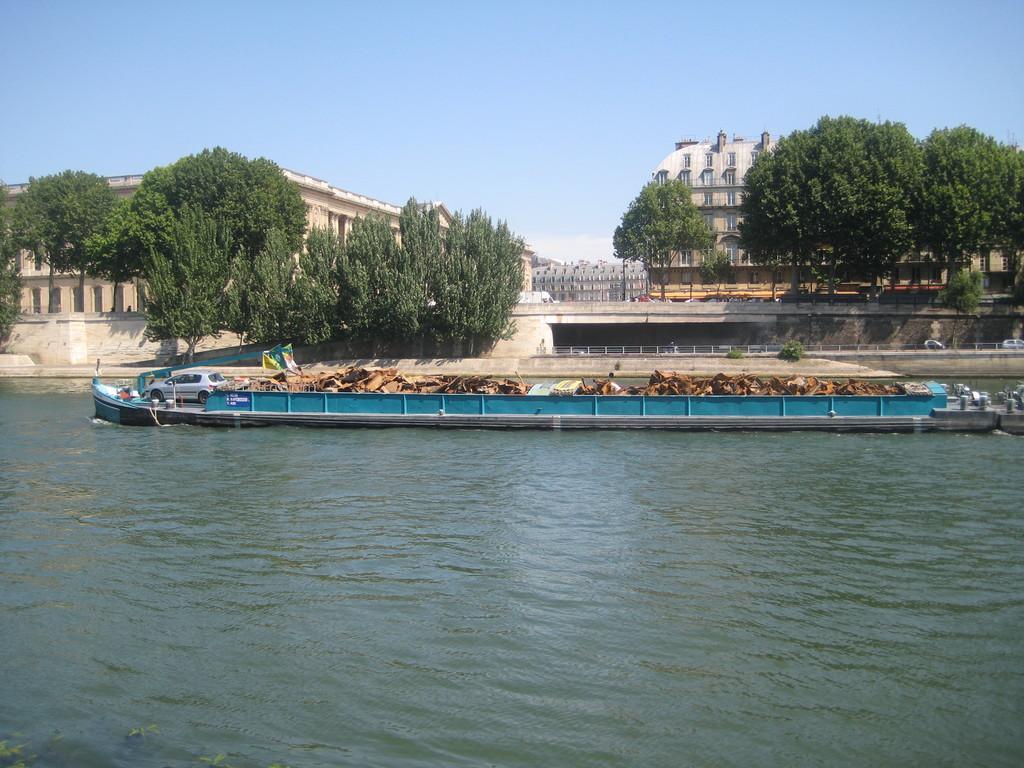Could you give a brief overview of what you see in this image? At the bottom of the image there is water and we can see a car. In the background there are trees, buildings and sky. 